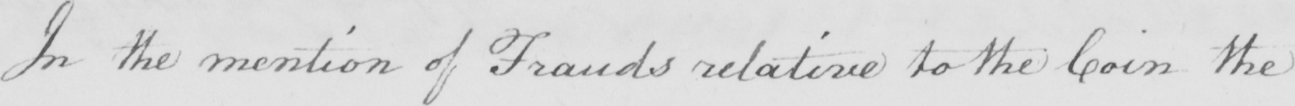What is written in this line of handwriting? In the mention of Frauds relative to the Coin the 